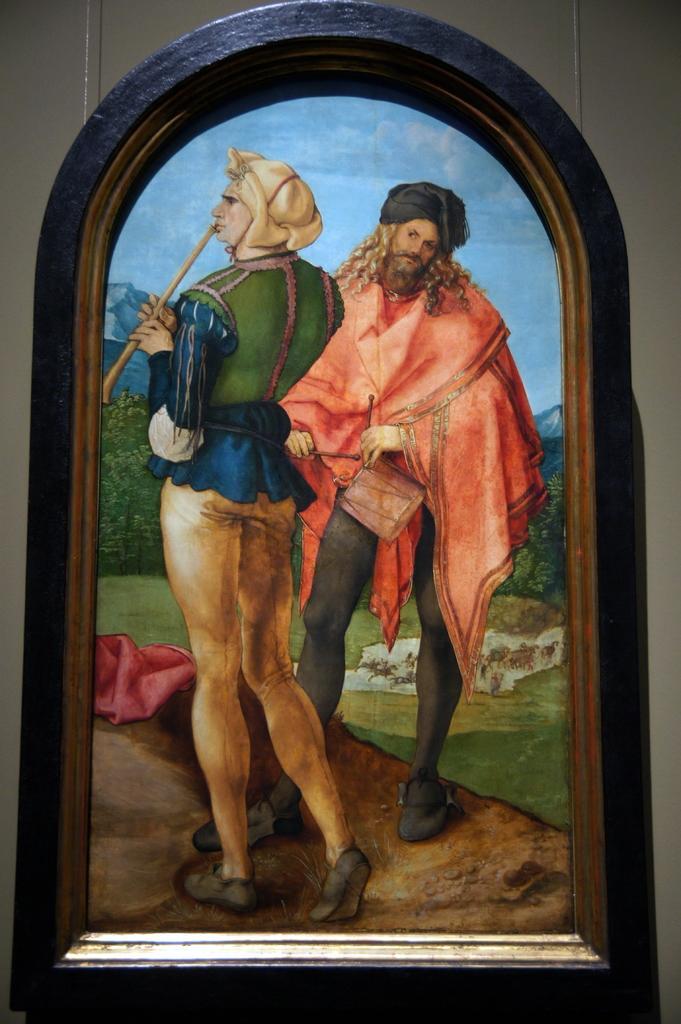Describe this image in one or two sentences. In the picture we can see a painting of a man and a woman are standing on the path and behind them we can see a grass surface and behind it we can see some plants, hills and sky. 